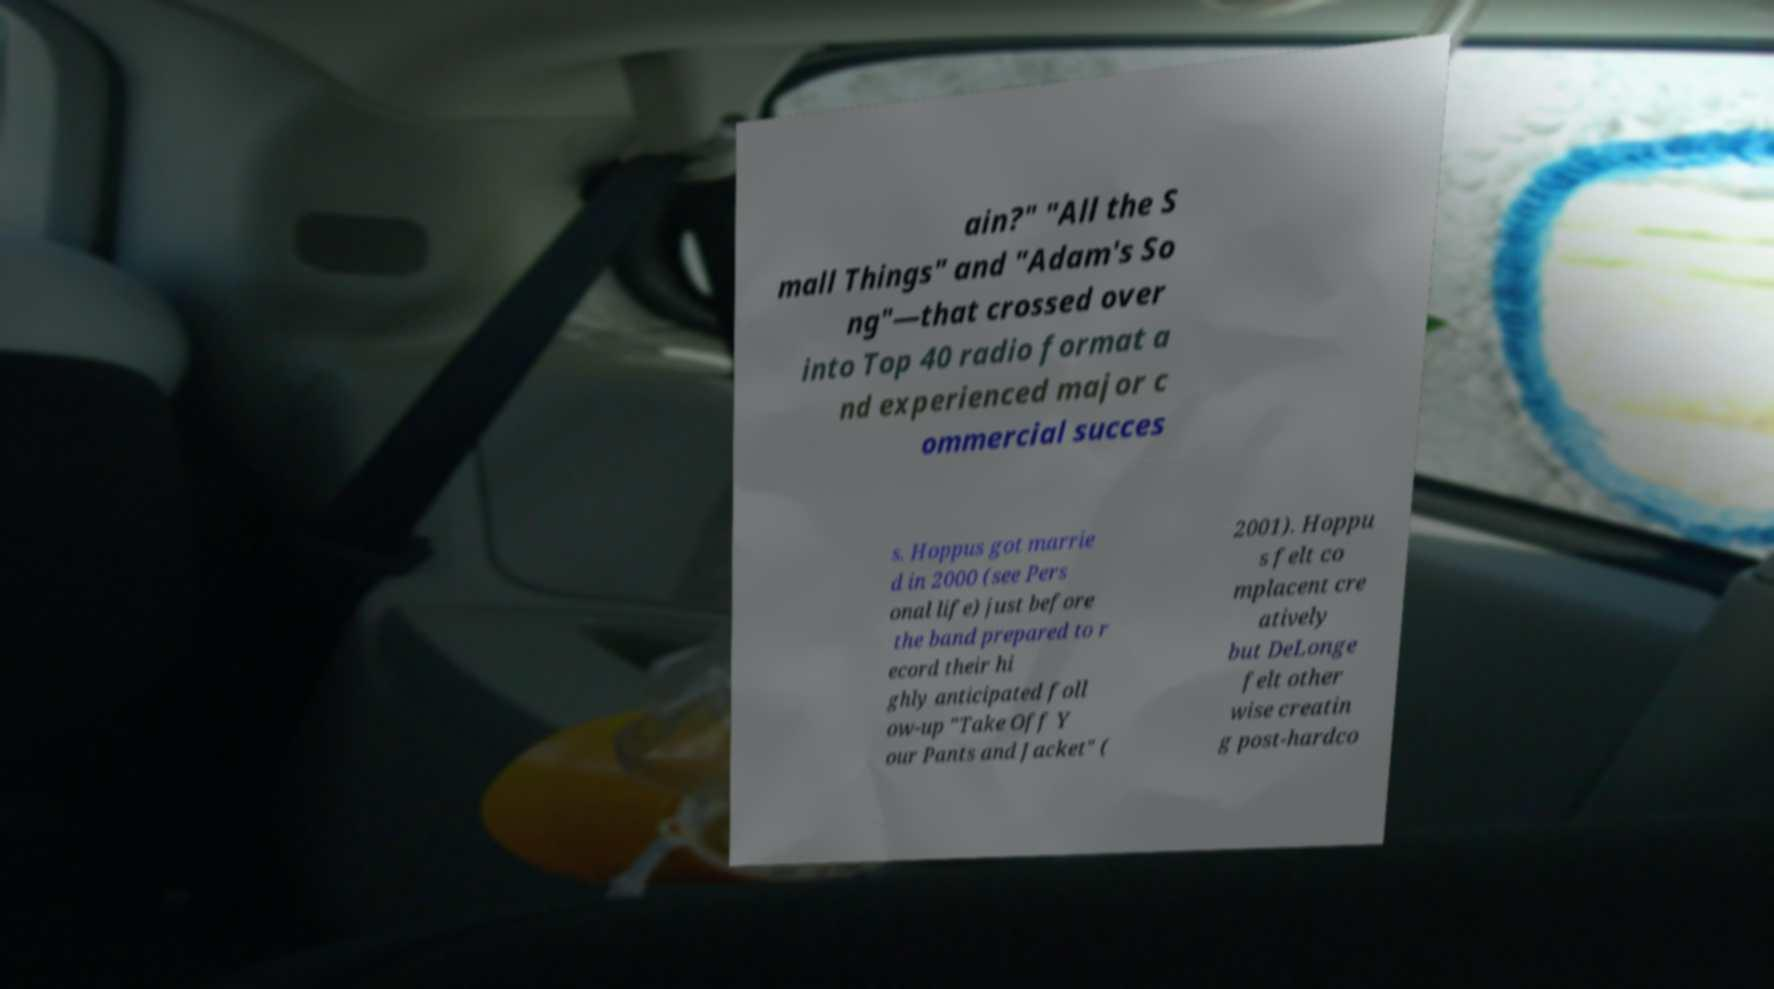Can you accurately transcribe the text from the provided image for me? ain?" "All the S mall Things" and "Adam's So ng"—that crossed over into Top 40 radio format a nd experienced major c ommercial succes s. Hoppus got marrie d in 2000 (see Pers onal life) just before the band prepared to r ecord their hi ghly anticipated foll ow-up "Take Off Y our Pants and Jacket" ( 2001). Hoppu s felt co mplacent cre atively but DeLonge felt other wise creatin g post-hardco 